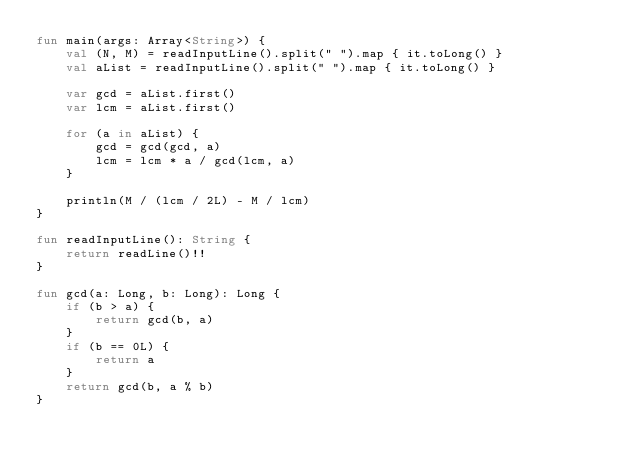Convert code to text. <code><loc_0><loc_0><loc_500><loc_500><_Kotlin_>fun main(args: Array<String>) {
    val (N, M) = readInputLine().split(" ").map { it.toLong() }
    val aList = readInputLine().split(" ").map { it.toLong() }

    var gcd = aList.first()
    var lcm = aList.first()

    for (a in aList) {
        gcd = gcd(gcd, a)
        lcm = lcm * a / gcd(lcm, a)
    }

    println(M / (lcm / 2L) - M / lcm)
}

fun readInputLine(): String {
    return readLine()!!
}

fun gcd(a: Long, b: Long): Long {
    if (b > a) {
        return gcd(b, a)
    }
    if (b == 0L) {
        return a
    }
    return gcd(b, a % b)
}
</code> 